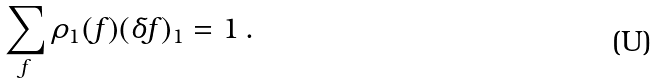Convert formula to latex. <formula><loc_0><loc_0><loc_500><loc_500>\sum _ { f } \rho _ { 1 } ( f ) ( \delta f ) _ { 1 } = 1 \, .</formula> 